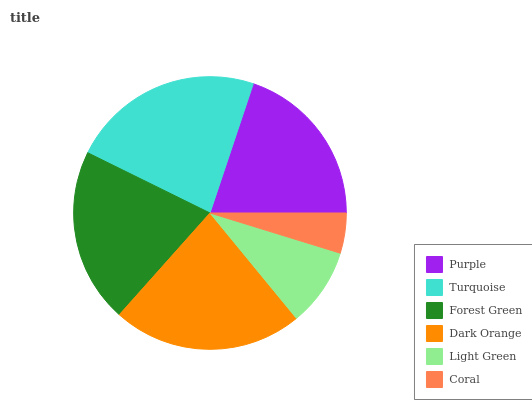Is Coral the minimum?
Answer yes or no. Yes. Is Turquoise the maximum?
Answer yes or no. Yes. Is Forest Green the minimum?
Answer yes or no. No. Is Forest Green the maximum?
Answer yes or no. No. Is Turquoise greater than Forest Green?
Answer yes or no. Yes. Is Forest Green less than Turquoise?
Answer yes or no. Yes. Is Forest Green greater than Turquoise?
Answer yes or no. No. Is Turquoise less than Forest Green?
Answer yes or no. No. Is Forest Green the high median?
Answer yes or no. Yes. Is Purple the low median?
Answer yes or no. Yes. Is Turquoise the high median?
Answer yes or no. No. Is Forest Green the low median?
Answer yes or no. No. 